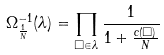Convert formula to latex. <formula><loc_0><loc_0><loc_500><loc_500>\Omega _ { \frac { 1 } { N } } ^ { - 1 } ( \lambda ) = \prod _ { \Box \in \lambda } \frac { 1 } { 1 + \frac { c ( \Box ) } { N } }</formula> 